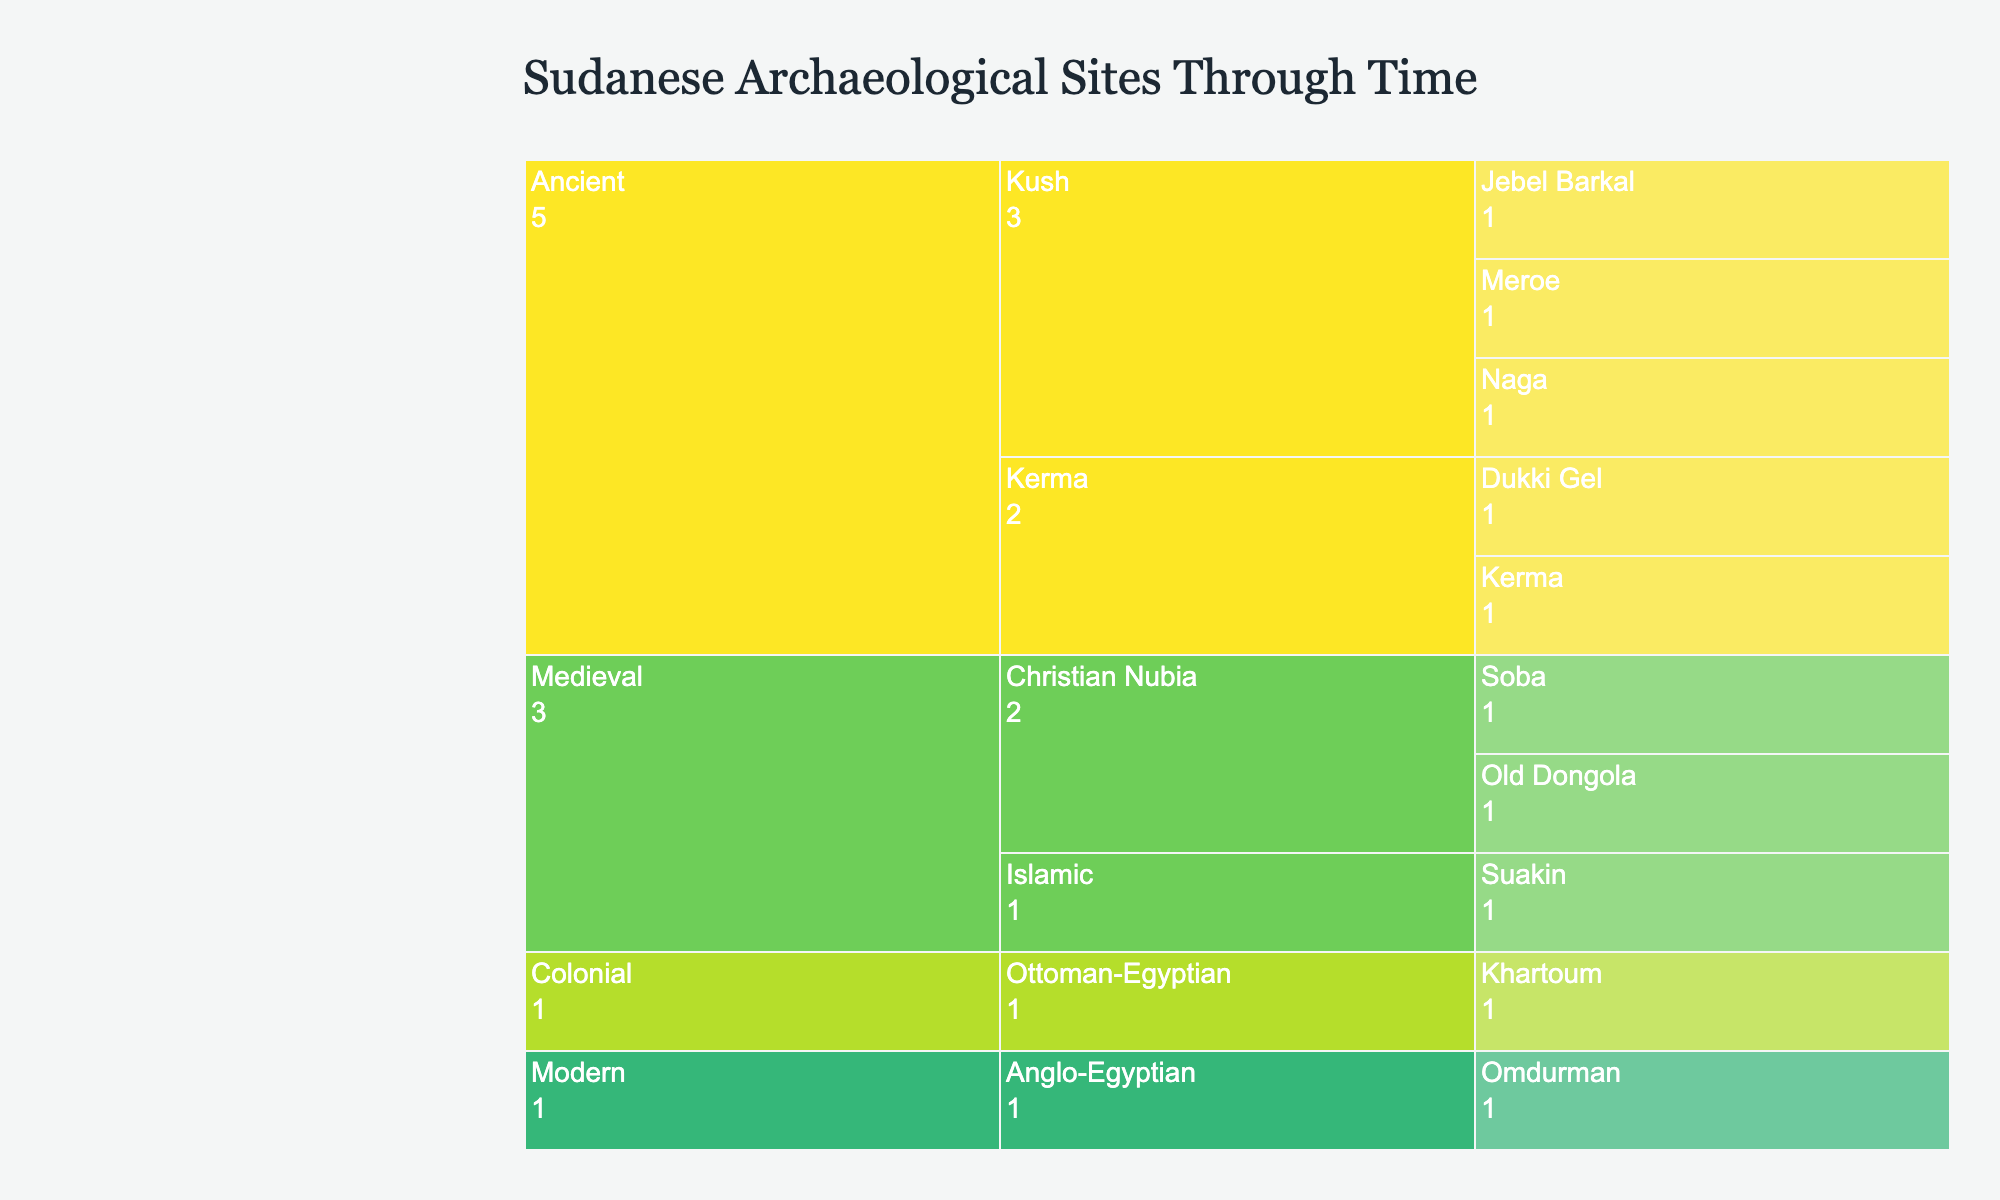What's the title of the figure? The title of a plot is usually located at the top and specifies what the visual is about. In this case, it reads: "Sudanese Archaeological Sites Through Time."
Answer: Sudanese Archaeological Sites Through Time What are the historical periods represented in the chart? Historical periods are shown at the top level of the icicle chart. The visible periods are "Ancient," "Medieval," "Colonial," and "Modern."
Answer: Ancient, Medieval, Colonial, Modern Which site has the significance labeled as "Capital of Alwa"? By examining the "Medieval" period, under the "Christian Nubia" era, you will find the site labeled "Soba" which is marked as "Capital of Alwa."
Answer: Soba How many eras are there within the "Ancient" period? The "Ancient" period can be expanded to reveal different eras. These include "Kerma" and "Kush." Count these eras.
Answer: 2 Compare the significance of the sites Meroe and Soba. First, locate each site on the chart. Meroe is under Ancient -> Kush and is labeled "Capital of Kushite Kingdom." Soba is under Medieval -> Christian Nubia and is labeled "Capital of Alwa." This shows both were capitals of significant kingdoms.
Answer: Both were capitals of significant kingdoms Which era has more sites, "Kerma" or "Christian Nubia"? Expanding each era, count the sites listed within them. "Kerma" includes 2 sites (Kerma, Dukki Gel) and "Christian Nubia" includes 2 sites (Old Dongola, Soba). Both have 2 sites each.
Answer: Equal number of sites (2 each) What is the site listed under the "Modern" period, and why is it significant? Expand the "Modern" period to reveal the era "Anglo-Egyptian" and the site "Omdurman." Its significance is "Mahdist capital."
Answer: Omdurman, Mahdist capital Calculate the total number of sites listed across all periods. Sum all the sites within each period. Ancient: 3 (Kerma) + 3 (Kush), Medieval: 2 (Christian Nubia) + 1 (Islamic), Colonial: 1 (Ottoman-Egyptian), Modern: 1 (Anglo-Egyptian). Total = (3+3) + (2+1) + 1 + 1 = 11.
Answer: 11 Which historical period has more significant capitals listed, Ancient or Medieval? The "Ancient" period lists 2 capitals (Kerma and Meroe) and the "Medieval" period also lists 2 capitals (Old Dongola and Soba). Both periods have the same number of significant capitals listed.
Answer: Equal number of significant capitals (2 each) What is the sacred mountain and royal necropolis site listed under the "Ancient" period? In the "Ancient" period, under the era "Kush," you will find "Jebel Barkal" marked as a "Sacred mountain and royal necropolis."
Answer: Jebel Barkal 